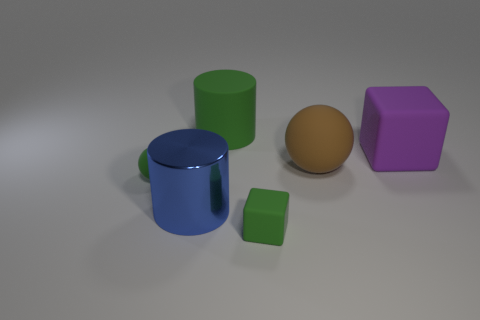What is the shape of the big rubber thing that is the same color as the tiny matte cube?
Provide a succinct answer. Cylinder. Does the small cube have the same color as the small ball?
Make the answer very short. Yes. What is the shape of the small thing in front of the tiny rubber thing that is to the left of the big blue shiny cylinder?
Your response must be concise. Cube. There is a green rubber thing that is the same shape as the large brown object; what size is it?
Your response must be concise. Small. What is the color of the rubber thing behind the purple rubber cube?
Offer a terse response. Green. What is the material of the large object on the right side of the rubber sphere to the right of the small green matte object that is on the right side of the large blue metal cylinder?
Your answer should be compact. Rubber. What is the size of the ball in front of the large brown rubber object behind the small matte ball?
Make the answer very short. Small. The big metal object that is the same shape as the big green rubber thing is what color?
Your answer should be compact. Blue. What number of tiny matte blocks have the same color as the big shiny cylinder?
Make the answer very short. 0. Does the brown object have the same size as the green cylinder?
Provide a succinct answer. Yes. 